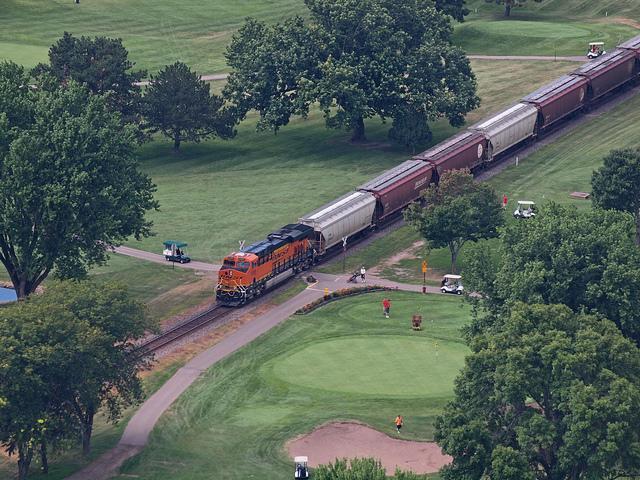How many train cars?
Give a very brief answer. 7. How many beds in this image require a ladder to get into?
Give a very brief answer. 0. 